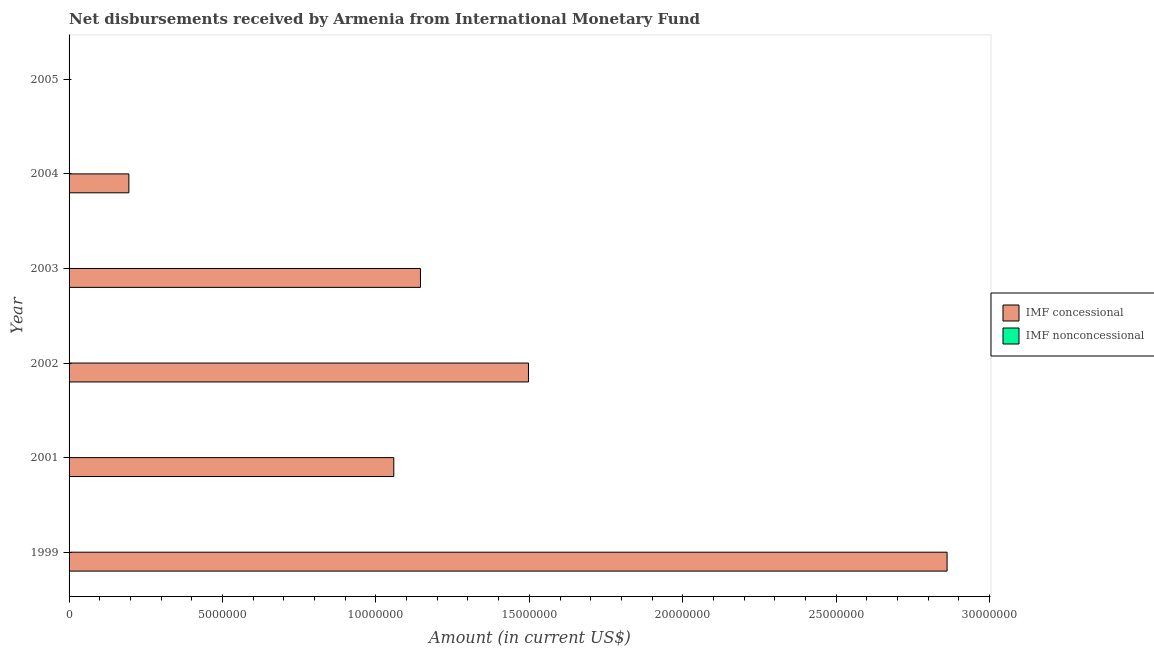How many different coloured bars are there?
Provide a succinct answer. 1. Are the number of bars per tick equal to the number of legend labels?
Your response must be concise. No. How many bars are there on the 6th tick from the bottom?
Provide a short and direct response. 0. What is the label of the 5th group of bars from the top?
Provide a succinct answer. 2001. What is the net concessional disbursements from imf in 2004?
Your response must be concise. 1.95e+06. Across all years, what is the maximum net concessional disbursements from imf?
Ensure brevity in your answer.  2.86e+07. What is the difference between the net concessional disbursements from imf in 2001 and that in 2002?
Keep it short and to the point. -4.39e+06. What is the difference between the net non concessional disbursements from imf in 2005 and the net concessional disbursements from imf in 2002?
Ensure brevity in your answer.  -1.50e+07. In how many years, is the net concessional disbursements from imf greater than 3000000 US$?
Provide a short and direct response. 4. What is the ratio of the net concessional disbursements from imf in 2002 to that in 2003?
Your answer should be very brief. 1.31. Is the net concessional disbursements from imf in 2003 less than that in 2004?
Make the answer very short. No. What is the difference between the highest and the second highest net concessional disbursements from imf?
Your response must be concise. 1.36e+07. What is the difference between the highest and the lowest net concessional disbursements from imf?
Offer a terse response. 2.86e+07. In how many years, is the net concessional disbursements from imf greater than the average net concessional disbursements from imf taken over all years?
Ensure brevity in your answer.  3. Is the sum of the net concessional disbursements from imf in 2002 and 2004 greater than the maximum net non concessional disbursements from imf across all years?
Make the answer very short. Yes. How many bars are there?
Offer a terse response. 5. How many years are there in the graph?
Give a very brief answer. 6. Does the graph contain grids?
Ensure brevity in your answer.  No. What is the title of the graph?
Your answer should be very brief. Net disbursements received by Armenia from International Monetary Fund. What is the label or title of the Y-axis?
Your answer should be very brief. Year. What is the Amount (in current US$) in IMF concessional in 1999?
Give a very brief answer. 2.86e+07. What is the Amount (in current US$) of IMF concessional in 2001?
Give a very brief answer. 1.06e+07. What is the Amount (in current US$) of IMF concessional in 2002?
Your response must be concise. 1.50e+07. What is the Amount (in current US$) of IMF concessional in 2003?
Provide a short and direct response. 1.15e+07. What is the Amount (in current US$) in IMF nonconcessional in 2003?
Offer a terse response. 0. What is the Amount (in current US$) in IMF concessional in 2004?
Your response must be concise. 1.95e+06. What is the Amount (in current US$) of IMF nonconcessional in 2004?
Make the answer very short. 0. What is the Amount (in current US$) of IMF concessional in 2005?
Offer a terse response. 0. Across all years, what is the maximum Amount (in current US$) of IMF concessional?
Your response must be concise. 2.86e+07. What is the total Amount (in current US$) of IMF concessional in the graph?
Your response must be concise. 6.76e+07. What is the total Amount (in current US$) of IMF nonconcessional in the graph?
Provide a short and direct response. 0. What is the difference between the Amount (in current US$) in IMF concessional in 1999 and that in 2001?
Ensure brevity in your answer.  1.80e+07. What is the difference between the Amount (in current US$) in IMF concessional in 1999 and that in 2002?
Provide a succinct answer. 1.36e+07. What is the difference between the Amount (in current US$) in IMF concessional in 1999 and that in 2003?
Give a very brief answer. 1.72e+07. What is the difference between the Amount (in current US$) of IMF concessional in 1999 and that in 2004?
Your response must be concise. 2.67e+07. What is the difference between the Amount (in current US$) in IMF concessional in 2001 and that in 2002?
Give a very brief answer. -4.39e+06. What is the difference between the Amount (in current US$) in IMF concessional in 2001 and that in 2003?
Offer a terse response. -8.70e+05. What is the difference between the Amount (in current US$) in IMF concessional in 2001 and that in 2004?
Keep it short and to the point. 8.63e+06. What is the difference between the Amount (in current US$) of IMF concessional in 2002 and that in 2003?
Keep it short and to the point. 3.52e+06. What is the difference between the Amount (in current US$) in IMF concessional in 2002 and that in 2004?
Your answer should be compact. 1.30e+07. What is the difference between the Amount (in current US$) of IMF concessional in 2003 and that in 2004?
Keep it short and to the point. 9.50e+06. What is the average Amount (in current US$) in IMF concessional per year?
Offer a terse response. 1.13e+07. What is the average Amount (in current US$) in IMF nonconcessional per year?
Your response must be concise. 0. What is the ratio of the Amount (in current US$) of IMF concessional in 1999 to that in 2001?
Offer a very short reply. 2.7. What is the ratio of the Amount (in current US$) of IMF concessional in 1999 to that in 2002?
Provide a short and direct response. 1.91. What is the ratio of the Amount (in current US$) in IMF concessional in 1999 to that in 2003?
Your answer should be compact. 2.5. What is the ratio of the Amount (in current US$) in IMF concessional in 1999 to that in 2004?
Offer a terse response. 14.68. What is the ratio of the Amount (in current US$) in IMF concessional in 2001 to that in 2002?
Your response must be concise. 0.71. What is the ratio of the Amount (in current US$) of IMF concessional in 2001 to that in 2003?
Provide a succinct answer. 0.92. What is the ratio of the Amount (in current US$) in IMF concessional in 2001 to that in 2004?
Keep it short and to the point. 5.43. What is the ratio of the Amount (in current US$) of IMF concessional in 2002 to that in 2003?
Provide a succinct answer. 1.31. What is the ratio of the Amount (in current US$) of IMF concessional in 2002 to that in 2004?
Give a very brief answer. 7.68. What is the ratio of the Amount (in current US$) of IMF concessional in 2003 to that in 2004?
Your answer should be very brief. 5.88. What is the difference between the highest and the second highest Amount (in current US$) in IMF concessional?
Keep it short and to the point. 1.36e+07. What is the difference between the highest and the lowest Amount (in current US$) of IMF concessional?
Provide a short and direct response. 2.86e+07. 